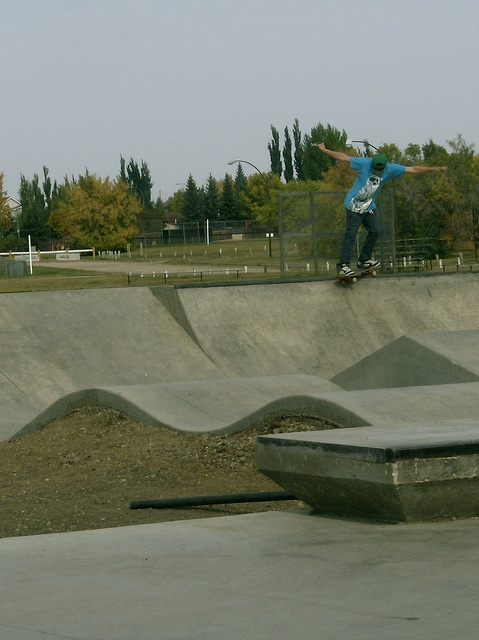Describe the objects in this image and their specific colors. I can see people in darkgray, black, teal, and darkgreen tones and skateboard in darkgray, darkgreen, black, and gray tones in this image. 